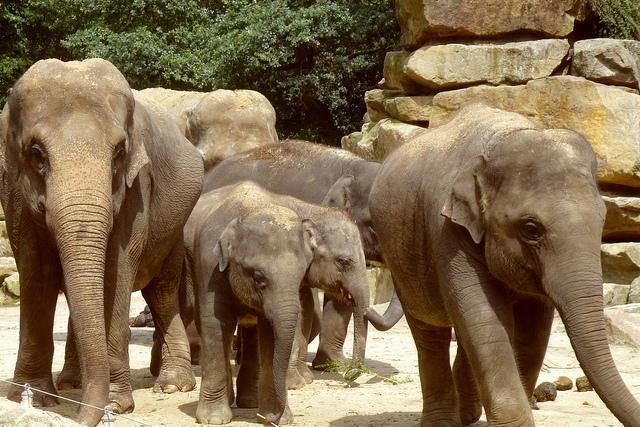How many elephants are young?
Give a very brief answer. 3. How many elephants are there?
Give a very brief answer. 6. 